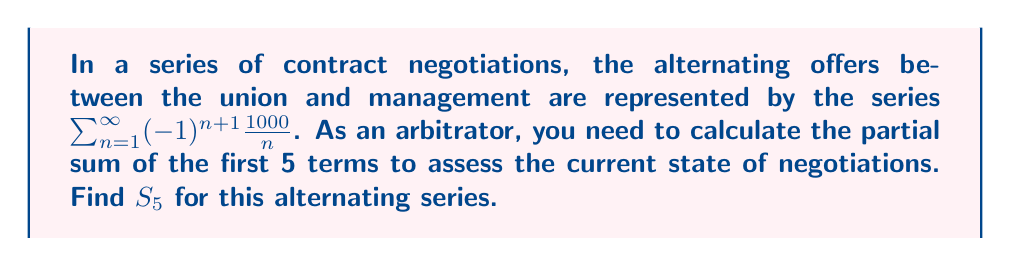Help me with this question. Let's approach this step-by-step:

1) The general term of the series is $a_n = (-1)^{n+1} \frac{1000}{n}$

2) We need to find $S_5 = \sum_{n=1}^{5} (-1)^{n+1} \frac{1000}{n}$

3) Let's calculate each term:

   For n = 1: $a_1 = (-1)^{1+1} \frac{1000}{1} = 1000$
   For n = 2: $a_2 = (-1)^{2+1} \frac{1000}{2} = -500$
   For n = 3: $a_3 = (-1)^{3+1} \frac{1000}{3} \approx 333.33$
   For n = 4: $a_4 = (-1)^{4+1} \frac{1000}{4} = -250$
   For n = 5: $a_5 = (-1)^{5+1} \frac{1000}{5} = 200$

4) Now, let's sum these terms:

   $S_5 = 1000 - 500 + 333.33 - 250 + 200$

5) Calculating this sum:

   $S_5 = 783.33$

Therefore, the partial sum of the first 5 terms is approximately 783.33.
Answer: $S_5 \approx 783.33$ 